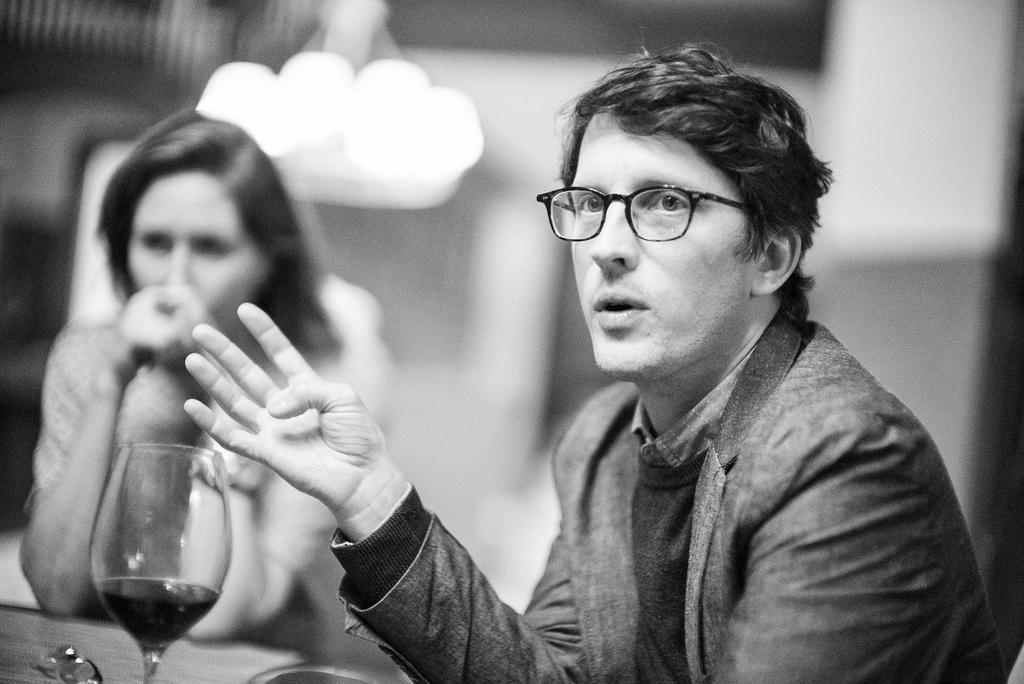In one or two sentences, can you explain what this image depicts? This is black and white picture,there are two people sitting and this man wore spectacle,in front this man we can see glass on the surface. In the background it is blur. 